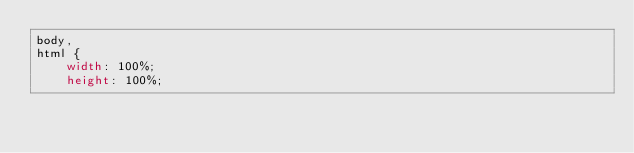<code> <loc_0><loc_0><loc_500><loc_500><_CSS_>body,
html {
    width: 100%;
    height: 100%;</code> 